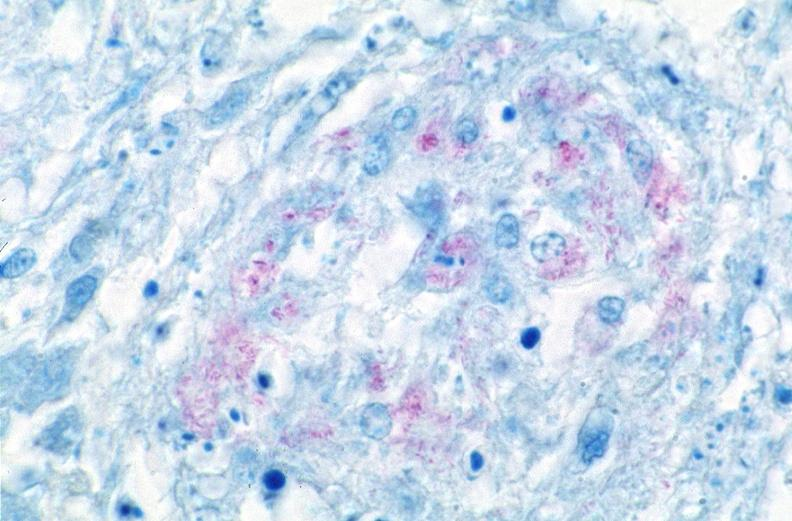s case of dic not bad photo present?
Answer the question using a single word or phrase. No 